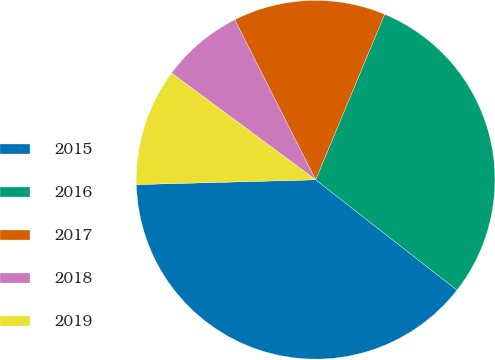<chart> <loc_0><loc_0><loc_500><loc_500><pie_chart><fcel>2015<fcel>2016<fcel>2017<fcel>2018<fcel>2019<nl><fcel>39.02%<fcel>29.26%<fcel>13.73%<fcel>7.41%<fcel>10.57%<nl></chart> 